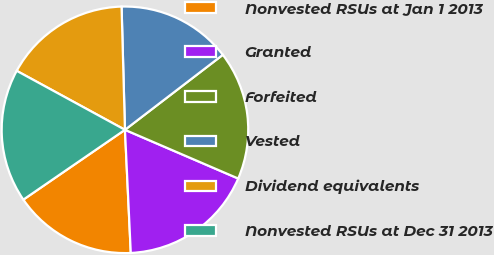Convert chart to OTSL. <chart><loc_0><loc_0><loc_500><loc_500><pie_chart><fcel>Nonvested RSUs at Jan 1 2013<fcel>Granted<fcel>Forfeited<fcel>Vested<fcel>Dividend equivalents<fcel>Nonvested RSUs at Dec 31 2013<nl><fcel>16.17%<fcel>17.78%<fcel>16.87%<fcel>15.03%<fcel>16.62%<fcel>17.52%<nl></chart> 